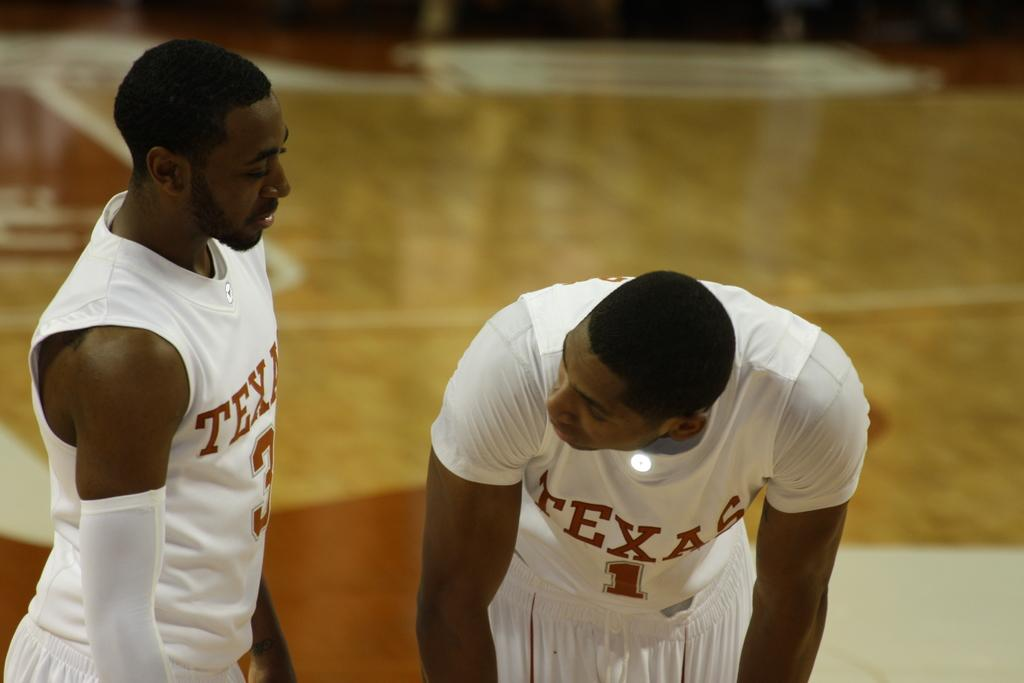<image>
Offer a succinct explanation of the picture presented. Two Texas basketball players wearing all white are seen talking to each other. 